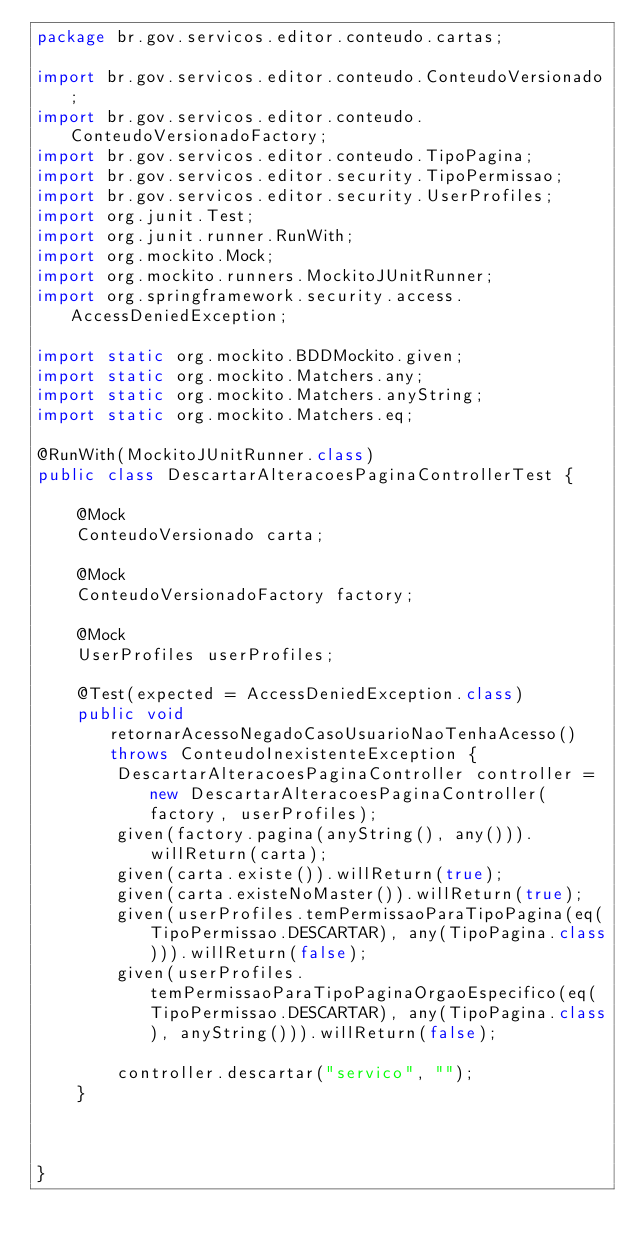Convert code to text. <code><loc_0><loc_0><loc_500><loc_500><_Java_>package br.gov.servicos.editor.conteudo.cartas;

import br.gov.servicos.editor.conteudo.ConteudoVersionado;
import br.gov.servicos.editor.conteudo.ConteudoVersionadoFactory;
import br.gov.servicos.editor.conteudo.TipoPagina;
import br.gov.servicos.editor.security.TipoPermissao;
import br.gov.servicos.editor.security.UserProfiles;
import org.junit.Test;
import org.junit.runner.RunWith;
import org.mockito.Mock;
import org.mockito.runners.MockitoJUnitRunner;
import org.springframework.security.access.AccessDeniedException;

import static org.mockito.BDDMockito.given;
import static org.mockito.Matchers.any;
import static org.mockito.Matchers.anyString;
import static org.mockito.Matchers.eq;

@RunWith(MockitoJUnitRunner.class)
public class DescartarAlteracoesPaginaControllerTest {

    @Mock
    ConteudoVersionado carta;

    @Mock
    ConteudoVersionadoFactory factory;

    @Mock
    UserProfiles userProfiles;

    @Test(expected = AccessDeniedException.class)
    public void retornarAcessoNegadoCasoUsuarioNaoTenhaAcesso() throws ConteudoInexistenteException {
        DescartarAlteracoesPaginaController controller = new DescartarAlteracoesPaginaController(factory, userProfiles);
        given(factory.pagina(anyString(), any())).willReturn(carta);
        given(carta.existe()).willReturn(true);
        given(carta.existeNoMaster()).willReturn(true);
        given(userProfiles.temPermissaoParaTipoPagina(eq(TipoPermissao.DESCARTAR), any(TipoPagina.class))).willReturn(false);
        given(userProfiles.temPermissaoParaTipoPaginaOrgaoEspecifico(eq(TipoPermissao.DESCARTAR), any(TipoPagina.class), anyString())).willReturn(false);

        controller.descartar("servico", "");
    }



}</code> 